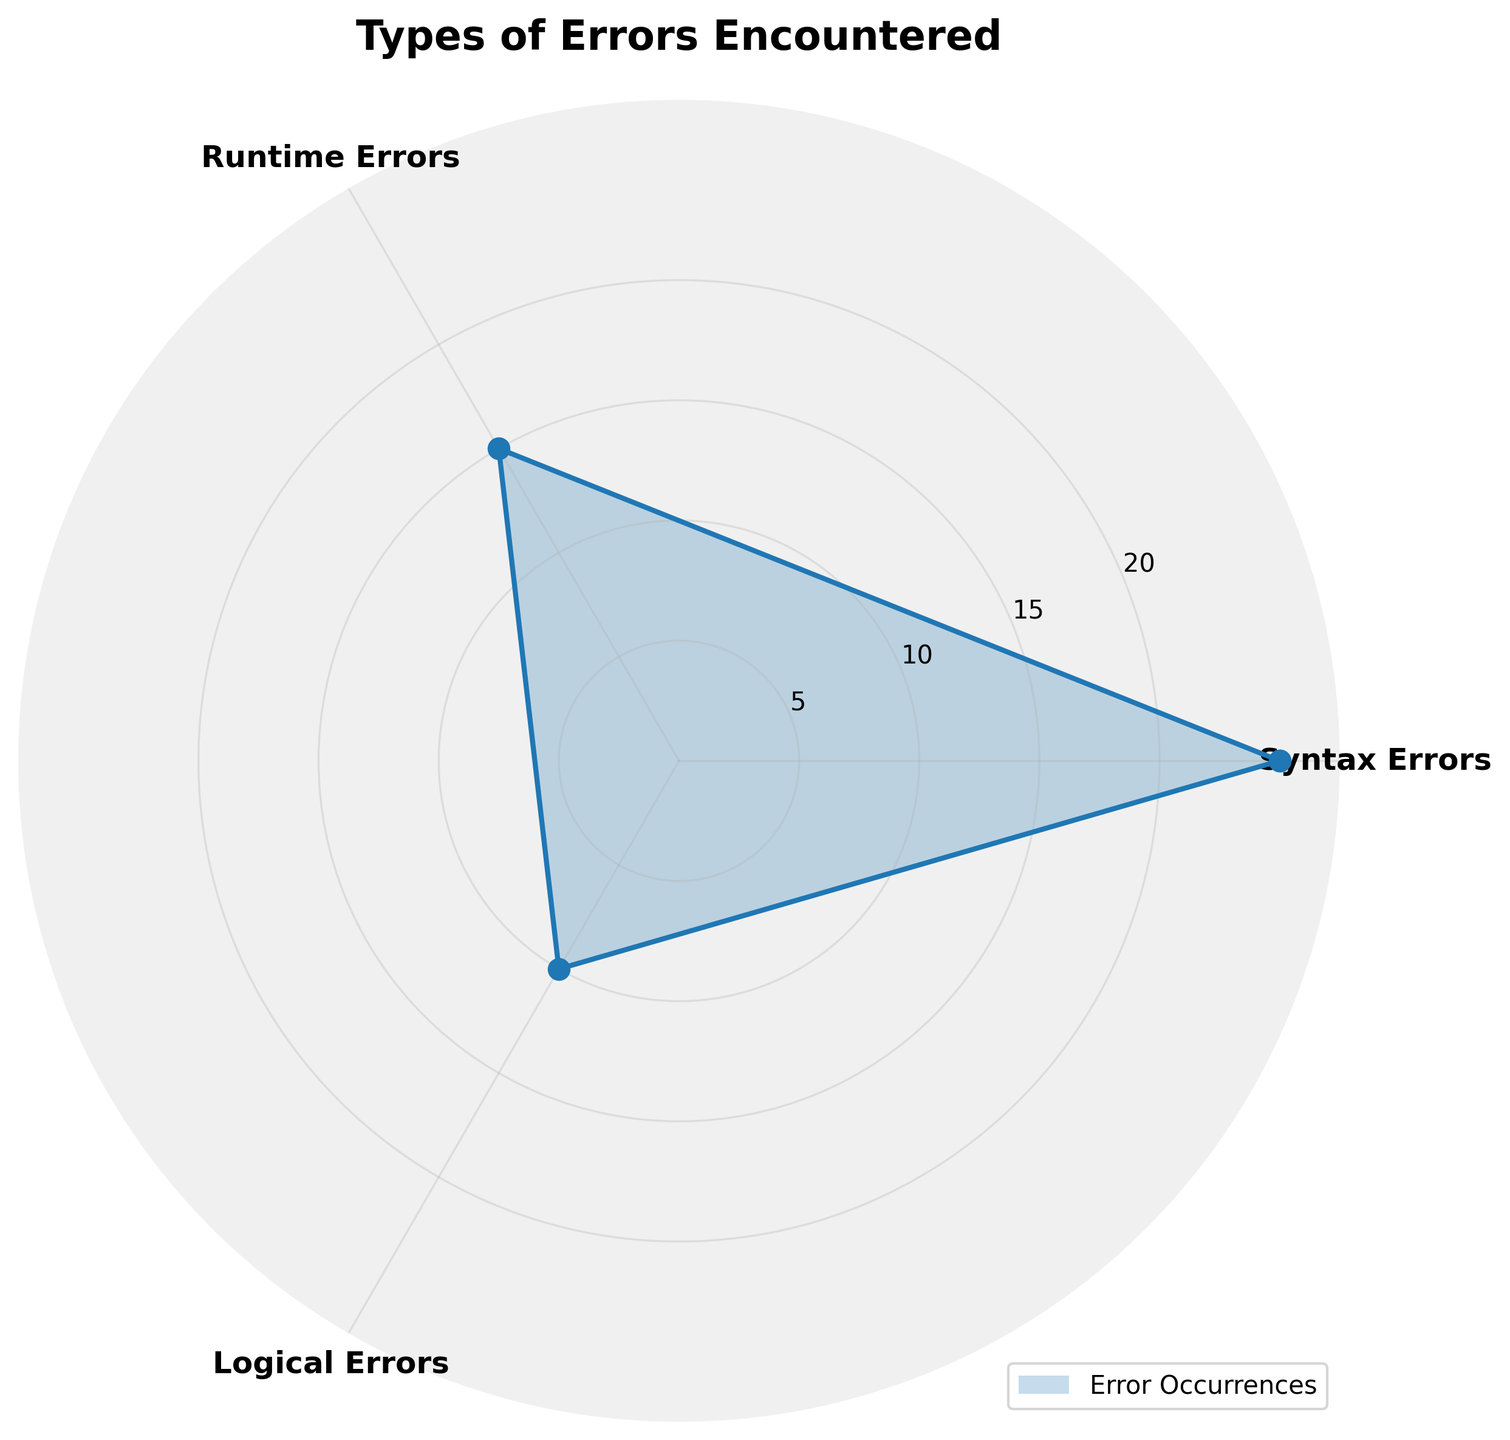What's the title of the chart? The title of the chart is written at the top and usually summarizes the main topic of the plot. Here, it says "Types of Errors Encountered."
Answer: Types of Errors Encountered How many different types of errors are shown in the chart? You can tell by looking at the number of labels around the circle in the rose chart. Each label represents a different type of error.
Answer: 3 What type of error occurs the most? Look for the label corresponding to the longest spoke in the rose chart. The longest value signifies the type of error that occurs the most.
Answer: Syntax Errors How many more occurrences of Syntax Errors are there compared to Logical Errors? Locate the values for Syntax Errors and Logical Errors on the rose chart. Syntax Errors have 25 occurrences and Logical Errors have 10. Calculate the difference: 25 - 10.
Answer: 15 Which error type is represented by the shortest marker in the chart? Observe the spokes' lengths in the rose chart. The shortest marker corresponds to the type of error with the fewest occurrences.
Answer: Logical Errors What is the sum of occurrences for Runtime Errors and Logical Errors? Find the occurrences for Runtime Errors and Logical Errors from the chart. Runtime Errors have 15 occurrences, and Logical Errors have 10. Add them together: 15 + 10.
Answer: 25 How many types of errors have more than 10 occurrences? Count how many error types have spokes longer than the marker for 10 occurrences.
Answer: 2 What is the average number of occurrences across all three types of errors? Add the occurrences for all three error types (Syntax: 25, Runtime: 15, Logical: 10) and divide by 3. Calculation: (25 + 15 + 10) / 3.
Answer: 16.67 Is the occurrence of Runtime Errors more than the occurrence of Logical Errors? Compare the lengths of the markers for Runtime Errors and Logical Errors. Runtime Errors have 15 occurrences, while Logical Errors have 10.
Answer: Yes What are the names of the error types plotted on the chart? Read off the names of the labels displayed at the angles of the rose chart. These represent different types of errors.
Answer: Syntax Errors, Runtime Errors, Logical Errors 